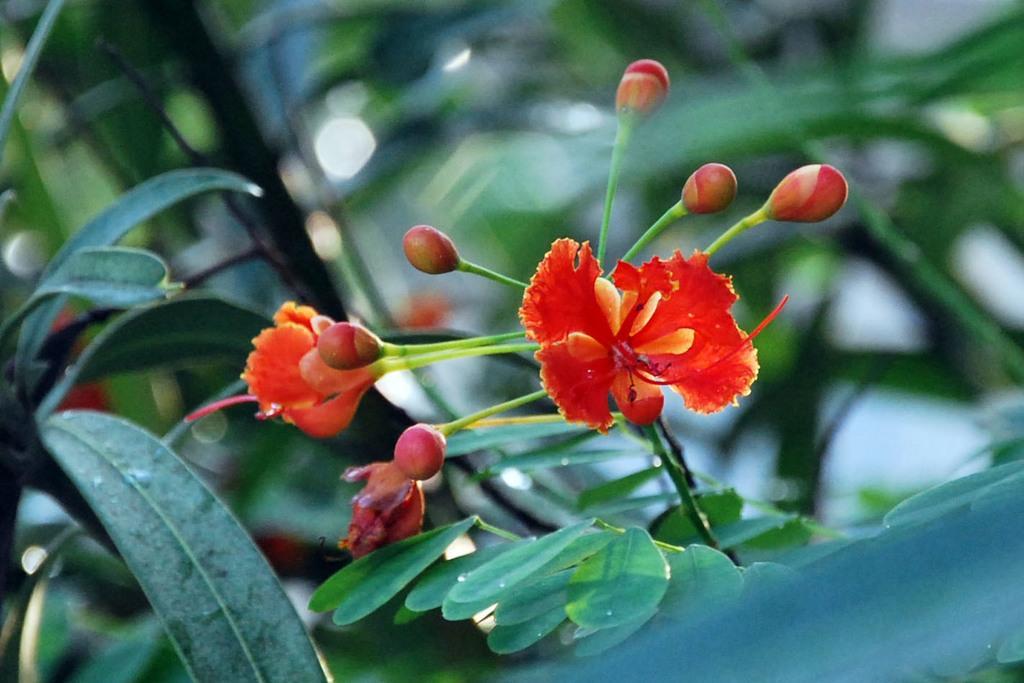Could you give a brief overview of what you see in this image? In this image there is a plant with red color flowers and buds, and there is blur background. 